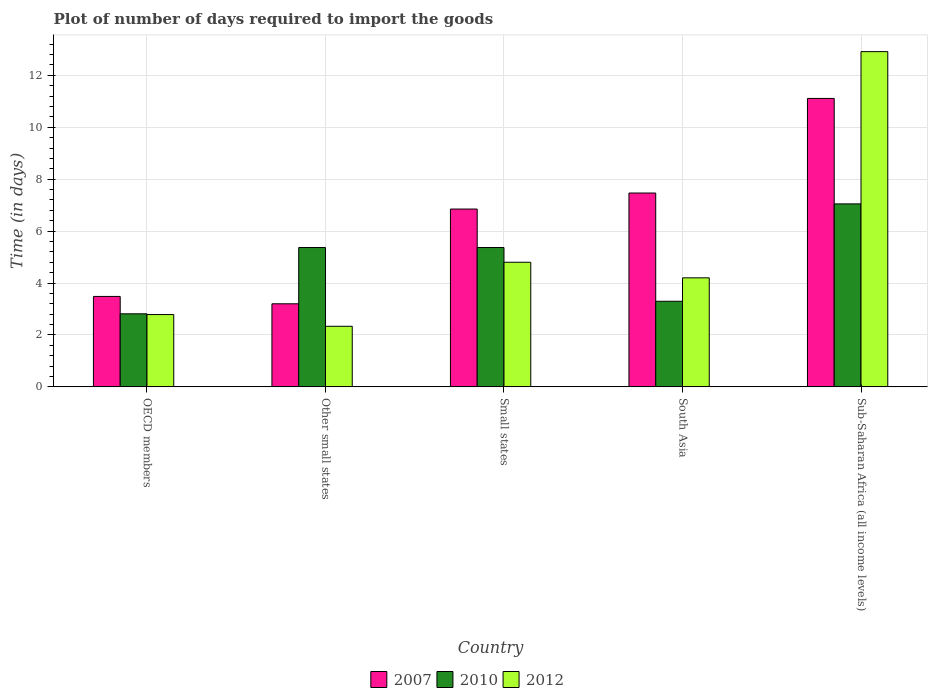Are the number of bars per tick equal to the number of legend labels?
Provide a succinct answer. Yes. Are the number of bars on each tick of the X-axis equal?
Offer a very short reply. Yes. In how many cases, is the number of bars for a given country not equal to the number of legend labels?
Offer a terse response. 0. What is the time required to import goods in 2010 in Other small states?
Provide a short and direct response. 5.37. Across all countries, what is the maximum time required to import goods in 2010?
Offer a terse response. 7.05. Across all countries, what is the minimum time required to import goods in 2010?
Your response must be concise. 2.81. In which country was the time required to import goods in 2012 maximum?
Make the answer very short. Sub-Saharan Africa (all income levels). In which country was the time required to import goods in 2012 minimum?
Your answer should be very brief. Other small states. What is the total time required to import goods in 2010 in the graph?
Your answer should be compact. 23.89. What is the difference between the time required to import goods in 2010 in Small states and that in South Asia?
Ensure brevity in your answer.  2.07. What is the difference between the time required to import goods in 2007 in OECD members and the time required to import goods in 2010 in South Asia?
Provide a succinct answer. 0.19. What is the average time required to import goods in 2010 per country?
Keep it short and to the point. 4.78. What is the difference between the time required to import goods of/in 2010 and time required to import goods of/in 2007 in Sub-Saharan Africa (all income levels)?
Your answer should be compact. -4.06. In how many countries, is the time required to import goods in 2012 greater than 12 days?
Provide a short and direct response. 1. What is the ratio of the time required to import goods in 2012 in OECD members to that in Other small states?
Give a very brief answer. 1.19. Is the time required to import goods in 2010 in Other small states less than that in South Asia?
Keep it short and to the point. No. Is the difference between the time required to import goods in 2010 in OECD members and Other small states greater than the difference between the time required to import goods in 2007 in OECD members and Other small states?
Provide a short and direct response. No. What is the difference between the highest and the second highest time required to import goods in 2007?
Keep it short and to the point. 4.26. What is the difference between the highest and the lowest time required to import goods in 2010?
Provide a succinct answer. 4.23. Is the sum of the time required to import goods in 2010 in Small states and Sub-Saharan Africa (all income levels) greater than the maximum time required to import goods in 2007 across all countries?
Provide a short and direct response. Yes. What does the 2nd bar from the right in OECD members represents?
Keep it short and to the point. 2010. How many bars are there?
Keep it short and to the point. 15. Are all the bars in the graph horizontal?
Ensure brevity in your answer.  No. How many countries are there in the graph?
Your response must be concise. 5. What is the difference between two consecutive major ticks on the Y-axis?
Offer a very short reply. 2. Does the graph contain any zero values?
Offer a terse response. No. Where does the legend appear in the graph?
Make the answer very short. Bottom center. How many legend labels are there?
Provide a short and direct response. 3. What is the title of the graph?
Your answer should be compact. Plot of number of days required to import the goods. What is the label or title of the X-axis?
Provide a succinct answer. Country. What is the label or title of the Y-axis?
Provide a short and direct response. Time (in days). What is the Time (in days) of 2007 in OECD members?
Offer a terse response. 3.48. What is the Time (in days) of 2010 in OECD members?
Your answer should be compact. 2.81. What is the Time (in days) in 2012 in OECD members?
Your answer should be compact. 2.79. What is the Time (in days) in 2007 in Other small states?
Keep it short and to the point. 3.2. What is the Time (in days) in 2010 in Other small states?
Offer a very short reply. 5.37. What is the Time (in days) of 2012 in Other small states?
Provide a short and direct response. 2.33. What is the Time (in days) of 2007 in Small states?
Give a very brief answer. 6.85. What is the Time (in days) of 2010 in Small states?
Make the answer very short. 5.37. What is the Time (in days) in 2012 in Small states?
Provide a succinct answer. 4.8. What is the Time (in days) in 2007 in South Asia?
Your answer should be compact. 7.47. What is the Time (in days) in 2010 in South Asia?
Provide a succinct answer. 3.3. What is the Time (in days) in 2007 in Sub-Saharan Africa (all income levels)?
Your response must be concise. 11.11. What is the Time (in days) of 2010 in Sub-Saharan Africa (all income levels)?
Your answer should be very brief. 7.05. What is the Time (in days) of 2012 in Sub-Saharan Africa (all income levels)?
Provide a short and direct response. 12.91. Across all countries, what is the maximum Time (in days) of 2007?
Give a very brief answer. 11.11. Across all countries, what is the maximum Time (in days) in 2010?
Keep it short and to the point. 7.05. Across all countries, what is the maximum Time (in days) in 2012?
Ensure brevity in your answer.  12.91. Across all countries, what is the minimum Time (in days) in 2010?
Your response must be concise. 2.81. Across all countries, what is the minimum Time (in days) in 2012?
Offer a very short reply. 2.33. What is the total Time (in days) of 2007 in the graph?
Provide a short and direct response. 32.11. What is the total Time (in days) in 2010 in the graph?
Ensure brevity in your answer.  23.89. What is the total Time (in days) in 2012 in the graph?
Ensure brevity in your answer.  27.03. What is the difference between the Time (in days) in 2007 in OECD members and that in Other small states?
Provide a short and direct response. 0.28. What is the difference between the Time (in days) of 2010 in OECD members and that in Other small states?
Provide a short and direct response. -2.55. What is the difference between the Time (in days) in 2012 in OECD members and that in Other small states?
Offer a terse response. 0.45. What is the difference between the Time (in days) in 2007 in OECD members and that in Small states?
Make the answer very short. -3.37. What is the difference between the Time (in days) of 2010 in OECD members and that in Small states?
Make the answer very short. -2.55. What is the difference between the Time (in days) of 2012 in OECD members and that in Small states?
Provide a succinct answer. -2.01. What is the difference between the Time (in days) of 2007 in OECD members and that in South Asia?
Your response must be concise. -3.98. What is the difference between the Time (in days) in 2010 in OECD members and that in South Asia?
Keep it short and to the point. -0.48. What is the difference between the Time (in days) of 2012 in OECD members and that in South Asia?
Your response must be concise. -1.41. What is the difference between the Time (in days) in 2007 in OECD members and that in Sub-Saharan Africa (all income levels)?
Offer a terse response. -7.63. What is the difference between the Time (in days) in 2010 in OECD members and that in Sub-Saharan Africa (all income levels)?
Give a very brief answer. -4.23. What is the difference between the Time (in days) in 2012 in OECD members and that in Sub-Saharan Africa (all income levels)?
Your answer should be very brief. -10.13. What is the difference between the Time (in days) of 2007 in Other small states and that in Small states?
Offer a very short reply. -3.65. What is the difference between the Time (in days) in 2012 in Other small states and that in Small states?
Your answer should be compact. -2.47. What is the difference between the Time (in days) of 2007 in Other small states and that in South Asia?
Give a very brief answer. -4.27. What is the difference between the Time (in days) in 2010 in Other small states and that in South Asia?
Keep it short and to the point. 2.07. What is the difference between the Time (in days) of 2012 in Other small states and that in South Asia?
Keep it short and to the point. -1.87. What is the difference between the Time (in days) in 2007 in Other small states and that in Sub-Saharan Africa (all income levels)?
Offer a very short reply. -7.91. What is the difference between the Time (in days) in 2010 in Other small states and that in Sub-Saharan Africa (all income levels)?
Give a very brief answer. -1.68. What is the difference between the Time (in days) in 2012 in Other small states and that in Sub-Saharan Africa (all income levels)?
Offer a terse response. -10.58. What is the difference between the Time (in days) in 2007 in Small states and that in South Asia?
Keep it short and to the point. -0.62. What is the difference between the Time (in days) in 2010 in Small states and that in South Asia?
Offer a terse response. 2.07. What is the difference between the Time (in days) of 2012 in Small states and that in South Asia?
Your answer should be compact. 0.6. What is the difference between the Time (in days) in 2007 in Small states and that in Sub-Saharan Africa (all income levels)?
Give a very brief answer. -4.26. What is the difference between the Time (in days) in 2010 in Small states and that in Sub-Saharan Africa (all income levels)?
Keep it short and to the point. -1.68. What is the difference between the Time (in days) in 2012 in Small states and that in Sub-Saharan Africa (all income levels)?
Your answer should be very brief. -8.11. What is the difference between the Time (in days) in 2007 in South Asia and that in Sub-Saharan Africa (all income levels)?
Make the answer very short. -3.64. What is the difference between the Time (in days) of 2010 in South Asia and that in Sub-Saharan Africa (all income levels)?
Give a very brief answer. -3.75. What is the difference between the Time (in days) in 2012 in South Asia and that in Sub-Saharan Africa (all income levels)?
Your answer should be compact. -8.71. What is the difference between the Time (in days) in 2007 in OECD members and the Time (in days) in 2010 in Other small states?
Make the answer very short. -1.88. What is the difference between the Time (in days) in 2007 in OECD members and the Time (in days) in 2012 in Other small states?
Provide a short and direct response. 1.15. What is the difference between the Time (in days) of 2010 in OECD members and the Time (in days) of 2012 in Other small states?
Your answer should be very brief. 0.48. What is the difference between the Time (in days) in 2007 in OECD members and the Time (in days) in 2010 in Small states?
Provide a succinct answer. -1.88. What is the difference between the Time (in days) of 2007 in OECD members and the Time (in days) of 2012 in Small states?
Keep it short and to the point. -1.32. What is the difference between the Time (in days) in 2010 in OECD members and the Time (in days) in 2012 in Small states?
Keep it short and to the point. -1.99. What is the difference between the Time (in days) in 2007 in OECD members and the Time (in days) in 2010 in South Asia?
Provide a short and direct response. 0.19. What is the difference between the Time (in days) of 2007 in OECD members and the Time (in days) of 2012 in South Asia?
Your response must be concise. -0.72. What is the difference between the Time (in days) of 2010 in OECD members and the Time (in days) of 2012 in South Asia?
Your answer should be compact. -1.39. What is the difference between the Time (in days) in 2007 in OECD members and the Time (in days) in 2010 in Sub-Saharan Africa (all income levels)?
Keep it short and to the point. -3.56. What is the difference between the Time (in days) of 2007 in OECD members and the Time (in days) of 2012 in Sub-Saharan Africa (all income levels)?
Your answer should be very brief. -9.43. What is the difference between the Time (in days) of 2010 in OECD members and the Time (in days) of 2012 in Sub-Saharan Africa (all income levels)?
Ensure brevity in your answer.  -10.1. What is the difference between the Time (in days) in 2007 in Other small states and the Time (in days) in 2010 in Small states?
Keep it short and to the point. -2.17. What is the difference between the Time (in days) in 2010 in Other small states and the Time (in days) in 2012 in Small states?
Keep it short and to the point. 0.57. What is the difference between the Time (in days) of 2007 in Other small states and the Time (in days) of 2010 in South Asia?
Make the answer very short. -0.1. What is the difference between the Time (in days) in 2007 in Other small states and the Time (in days) in 2012 in South Asia?
Offer a very short reply. -1. What is the difference between the Time (in days) in 2010 in Other small states and the Time (in days) in 2012 in South Asia?
Ensure brevity in your answer.  1.17. What is the difference between the Time (in days) in 2007 in Other small states and the Time (in days) in 2010 in Sub-Saharan Africa (all income levels)?
Keep it short and to the point. -3.85. What is the difference between the Time (in days) of 2007 in Other small states and the Time (in days) of 2012 in Sub-Saharan Africa (all income levels)?
Make the answer very short. -9.71. What is the difference between the Time (in days) in 2010 in Other small states and the Time (in days) in 2012 in Sub-Saharan Africa (all income levels)?
Keep it short and to the point. -7.55. What is the difference between the Time (in days) of 2007 in Small states and the Time (in days) of 2010 in South Asia?
Ensure brevity in your answer.  3.55. What is the difference between the Time (in days) of 2007 in Small states and the Time (in days) of 2012 in South Asia?
Your answer should be compact. 2.65. What is the difference between the Time (in days) in 2010 in Small states and the Time (in days) in 2012 in South Asia?
Give a very brief answer. 1.17. What is the difference between the Time (in days) in 2007 in Small states and the Time (in days) in 2010 in Sub-Saharan Africa (all income levels)?
Ensure brevity in your answer.  -0.2. What is the difference between the Time (in days) of 2007 in Small states and the Time (in days) of 2012 in Sub-Saharan Africa (all income levels)?
Keep it short and to the point. -6.06. What is the difference between the Time (in days) of 2010 in Small states and the Time (in days) of 2012 in Sub-Saharan Africa (all income levels)?
Make the answer very short. -7.55. What is the difference between the Time (in days) of 2007 in South Asia and the Time (in days) of 2010 in Sub-Saharan Africa (all income levels)?
Your response must be concise. 0.42. What is the difference between the Time (in days) of 2007 in South Asia and the Time (in days) of 2012 in Sub-Saharan Africa (all income levels)?
Your answer should be compact. -5.45. What is the difference between the Time (in days) in 2010 in South Asia and the Time (in days) in 2012 in Sub-Saharan Africa (all income levels)?
Your response must be concise. -9.62. What is the average Time (in days) of 2007 per country?
Make the answer very short. 6.42. What is the average Time (in days) of 2010 per country?
Give a very brief answer. 4.78. What is the average Time (in days) in 2012 per country?
Offer a terse response. 5.41. What is the difference between the Time (in days) in 2007 and Time (in days) in 2010 in OECD members?
Provide a succinct answer. 0.67. What is the difference between the Time (in days) of 2007 and Time (in days) of 2012 in OECD members?
Ensure brevity in your answer.  0.7. What is the difference between the Time (in days) in 2010 and Time (in days) in 2012 in OECD members?
Your answer should be compact. 0.03. What is the difference between the Time (in days) in 2007 and Time (in days) in 2010 in Other small states?
Provide a succinct answer. -2.17. What is the difference between the Time (in days) in 2007 and Time (in days) in 2012 in Other small states?
Make the answer very short. 0.87. What is the difference between the Time (in days) in 2010 and Time (in days) in 2012 in Other small states?
Make the answer very short. 3.03. What is the difference between the Time (in days) of 2007 and Time (in days) of 2010 in Small states?
Your response must be concise. 1.48. What is the difference between the Time (in days) in 2007 and Time (in days) in 2012 in Small states?
Your response must be concise. 2.05. What is the difference between the Time (in days) of 2010 and Time (in days) of 2012 in Small states?
Your answer should be compact. 0.57. What is the difference between the Time (in days) of 2007 and Time (in days) of 2010 in South Asia?
Ensure brevity in your answer.  4.17. What is the difference between the Time (in days) of 2007 and Time (in days) of 2012 in South Asia?
Your answer should be very brief. 3.27. What is the difference between the Time (in days) of 2010 and Time (in days) of 2012 in South Asia?
Your response must be concise. -0.9. What is the difference between the Time (in days) in 2007 and Time (in days) in 2010 in Sub-Saharan Africa (all income levels)?
Offer a terse response. 4.06. What is the difference between the Time (in days) of 2007 and Time (in days) of 2012 in Sub-Saharan Africa (all income levels)?
Your answer should be very brief. -1.8. What is the difference between the Time (in days) in 2010 and Time (in days) in 2012 in Sub-Saharan Africa (all income levels)?
Your answer should be very brief. -5.86. What is the ratio of the Time (in days) in 2007 in OECD members to that in Other small states?
Keep it short and to the point. 1.09. What is the ratio of the Time (in days) of 2010 in OECD members to that in Other small states?
Provide a succinct answer. 0.52. What is the ratio of the Time (in days) in 2012 in OECD members to that in Other small states?
Your response must be concise. 1.19. What is the ratio of the Time (in days) of 2007 in OECD members to that in Small states?
Give a very brief answer. 0.51. What is the ratio of the Time (in days) in 2010 in OECD members to that in Small states?
Your answer should be compact. 0.52. What is the ratio of the Time (in days) in 2012 in OECD members to that in Small states?
Make the answer very short. 0.58. What is the ratio of the Time (in days) in 2007 in OECD members to that in South Asia?
Your response must be concise. 0.47. What is the ratio of the Time (in days) in 2010 in OECD members to that in South Asia?
Offer a terse response. 0.85. What is the ratio of the Time (in days) of 2012 in OECD members to that in South Asia?
Provide a short and direct response. 0.66. What is the ratio of the Time (in days) of 2007 in OECD members to that in Sub-Saharan Africa (all income levels)?
Make the answer very short. 0.31. What is the ratio of the Time (in days) in 2010 in OECD members to that in Sub-Saharan Africa (all income levels)?
Ensure brevity in your answer.  0.4. What is the ratio of the Time (in days) of 2012 in OECD members to that in Sub-Saharan Africa (all income levels)?
Your response must be concise. 0.22. What is the ratio of the Time (in days) in 2007 in Other small states to that in Small states?
Ensure brevity in your answer.  0.47. What is the ratio of the Time (in days) of 2010 in Other small states to that in Small states?
Your answer should be very brief. 1. What is the ratio of the Time (in days) in 2012 in Other small states to that in Small states?
Offer a very short reply. 0.49. What is the ratio of the Time (in days) in 2007 in Other small states to that in South Asia?
Your answer should be compact. 0.43. What is the ratio of the Time (in days) of 2010 in Other small states to that in South Asia?
Provide a short and direct response. 1.63. What is the ratio of the Time (in days) of 2012 in Other small states to that in South Asia?
Your answer should be very brief. 0.56. What is the ratio of the Time (in days) in 2007 in Other small states to that in Sub-Saharan Africa (all income levels)?
Ensure brevity in your answer.  0.29. What is the ratio of the Time (in days) of 2010 in Other small states to that in Sub-Saharan Africa (all income levels)?
Offer a terse response. 0.76. What is the ratio of the Time (in days) of 2012 in Other small states to that in Sub-Saharan Africa (all income levels)?
Make the answer very short. 0.18. What is the ratio of the Time (in days) in 2007 in Small states to that in South Asia?
Provide a succinct answer. 0.92. What is the ratio of the Time (in days) in 2010 in Small states to that in South Asia?
Offer a very short reply. 1.63. What is the ratio of the Time (in days) in 2007 in Small states to that in Sub-Saharan Africa (all income levels)?
Your answer should be very brief. 0.62. What is the ratio of the Time (in days) in 2010 in Small states to that in Sub-Saharan Africa (all income levels)?
Ensure brevity in your answer.  0.76. What is the ratio of the Time (in days) in 2012 in Small states to that in Sub-Saharan Africa (all income levels)?
Offer a very short reply. 0.37. What is the ratio of the Time (in days) in 2007 in South Asia to that in Sub-Saharan Africa (all income levels)?
Offer a terse response. 0.67. What is the ratio of the Time (in days) of 2010 in South Asia to that in Sub-Saharan Africa (all income levels)?
Provide a short and direct response. 0.47. What is the ratio of the Time (in days) of 2012 in South Asia to that in Sub-Saharan Africa (all income levels)?
Make the answer very short. 0.33. What is the difference between the highest and the second highest Time (in days) of 2007?
Offer a very short reply. 3.64. What is the difference between the highest and the second highest Time (in days) in 2010?
Ensure brevity in your answer.  1.68. What is the difference between the highest and the second highest Time (in days) of 2012?
Give a very brief answer. 8.11. What is the difference between the highest and the lowest Time (in days) of 2007?
Your answer should be very brief. 7.91. What is the difference between the highest and the lowest Time (in days) in 2010?
Provide a short and direct response. 4.23. What is the difference between the highest and the lowest Time (in days) of 2012?
Provide a short and direct response. 10.58. 